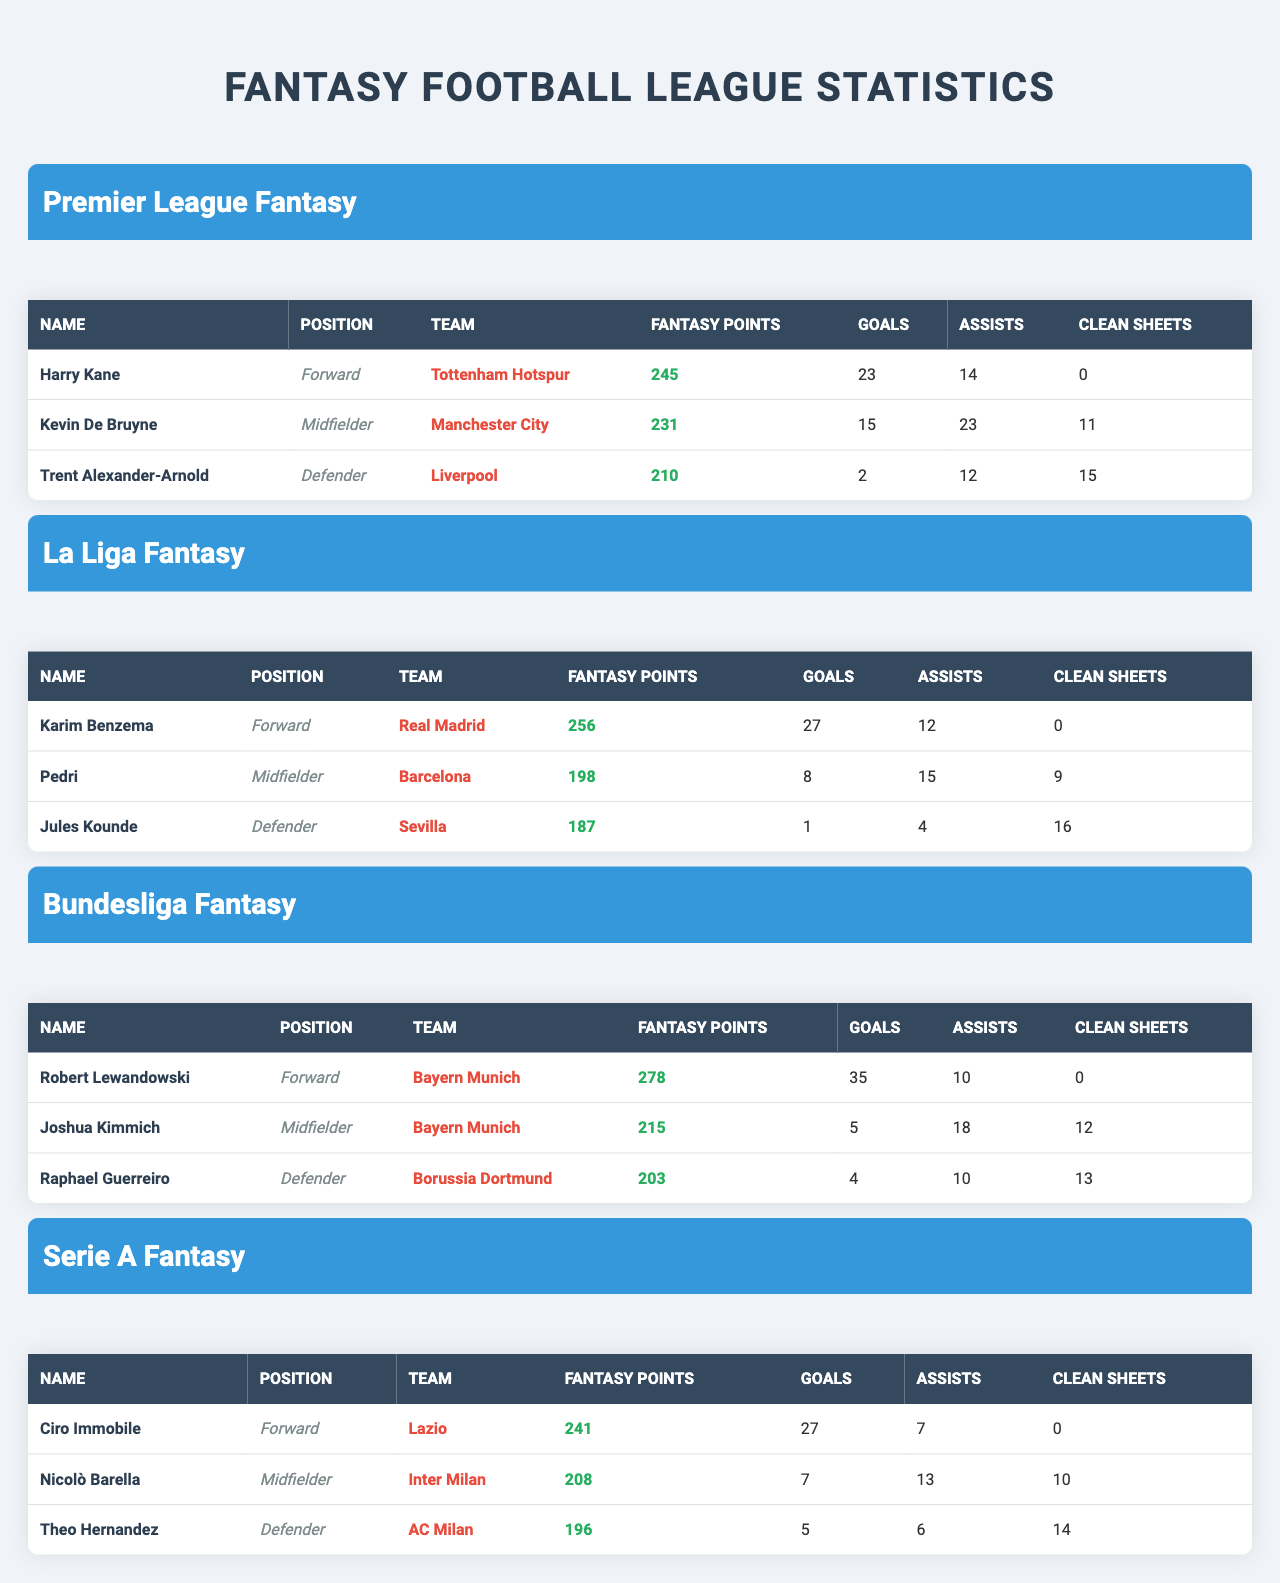What is the highest fantasy points scored among the players in the Bundesliga Fantasy League? Robert Lewandowski scored 278 points in the Bundesliga Fantasy League, which is the highest when compared to the other players listed.
Answer: 278 Who has more goals, Harry Kane or Ciro Immobile? Harry Kane scored 23 goals, while Ciro Immobile scored 27 goals. Therefore, Ciro Immobile has more goals than Harry Kane.
Answer: Ciro Immobile Which player has the most clean sheets in the Premier League Fantasy? Trent Alexander-Arnold has 15 clean sheets, which is more than the other players in the Premier League Fantasy League.
Answer: 15 If we consider the goals scored by players from all leagues, who has the highest total? Combining the goals from all leagues: Lewandowski (35) + Benzema (27) + Immobile (27) + Kane (23) = 112 goals. Lewandowski has the highest individual total with 35 goals, but cumulatively it sums to 112.
Answer: 112 Is it true that Kevin De Bruyne has more assists than Joshua Kimmich? Kevin De Bruyne has 23 assists, while Joshua Kimmich has 18 assists, confirming that De Bruyne indeed has more assists.
Answer: Yes What is the average fantasy points scored by top players in the Serie A Fantasy? The total fantasy points for Serie A players is 241 + 208 + 196 = 645. There are 3 players, so the average is 645/3 = 215.
Answer: 215 Who is the top scoring midfielder in the La Liga Fantasy League? Karim Benzema, although primarily a forward, has the most fantasy points in La Liga but does not qualify as a midfielder. Pedri, a midfielder, has 198 points, making him the top midfielder.
Answer: Pedri Which defender has the least fantasy points across all leagues? Jules Kounde from La Liga Fantasy has the least fantasy points among defenders, having scored 187 points.
Answer: 187 What is the difference in fantasy points between the top players from the Premier League Fantasy and Bundesliga Fantasy League? Premier League top player Harry Kane has 245 points, while Bundesliga top player Robert Lewandowski has 278 points. The difference is 278 - 245 = 33 points.
Answer: 33 If you sum up the clean sheets of all players in La Liga Fantasy, what would it be? The total clean sheets for La Liga fantasy players is 0 (Benzema) + 9 (Pedri) + 16 (Kounde) = 25 clean sheets total.
Answer: 25 